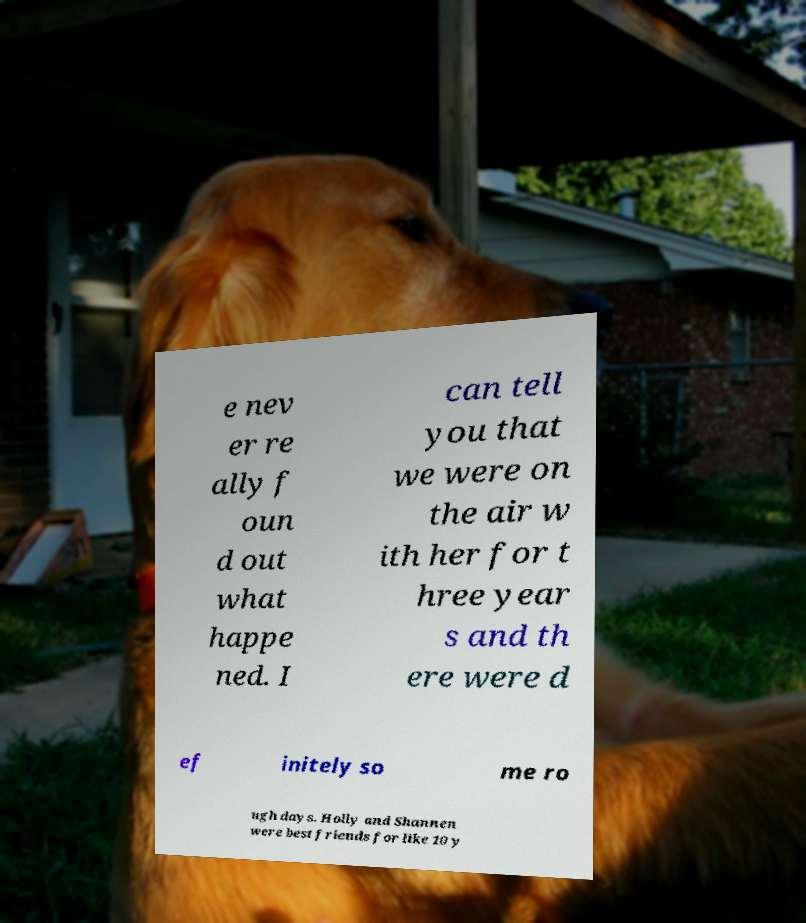I need the written content from this picture converted into text. Can you do that? e nev er re ally f oun d out what happe ned. I can tell you that we were on the air w ith her for t hree year s and th ere were d ef initely so me ro ugh days. Holly and Shannen were best friends for like 10 y 